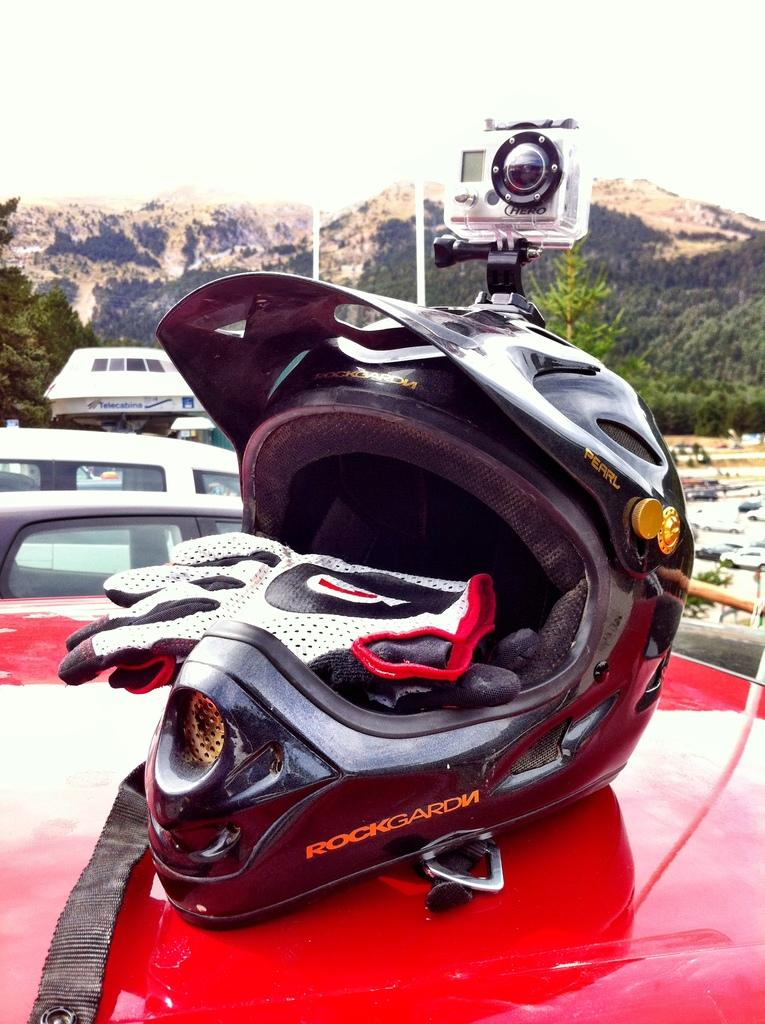What protective gear is visible in the image? There is a helmet and a pair of gloves in the image. What is attached to the helmet? A camera is mounted on the helmet. What type of landscape can be seen in the background of the image? There are mountains visible in the background of the image. What degree of difficulty is the swimmer attempting in the image? There is no swimmer or swimming activity present in the image. How does the steam affect the visibility of the mountains in the image? There is no steam present in the image; the mountains are clearly visible. 